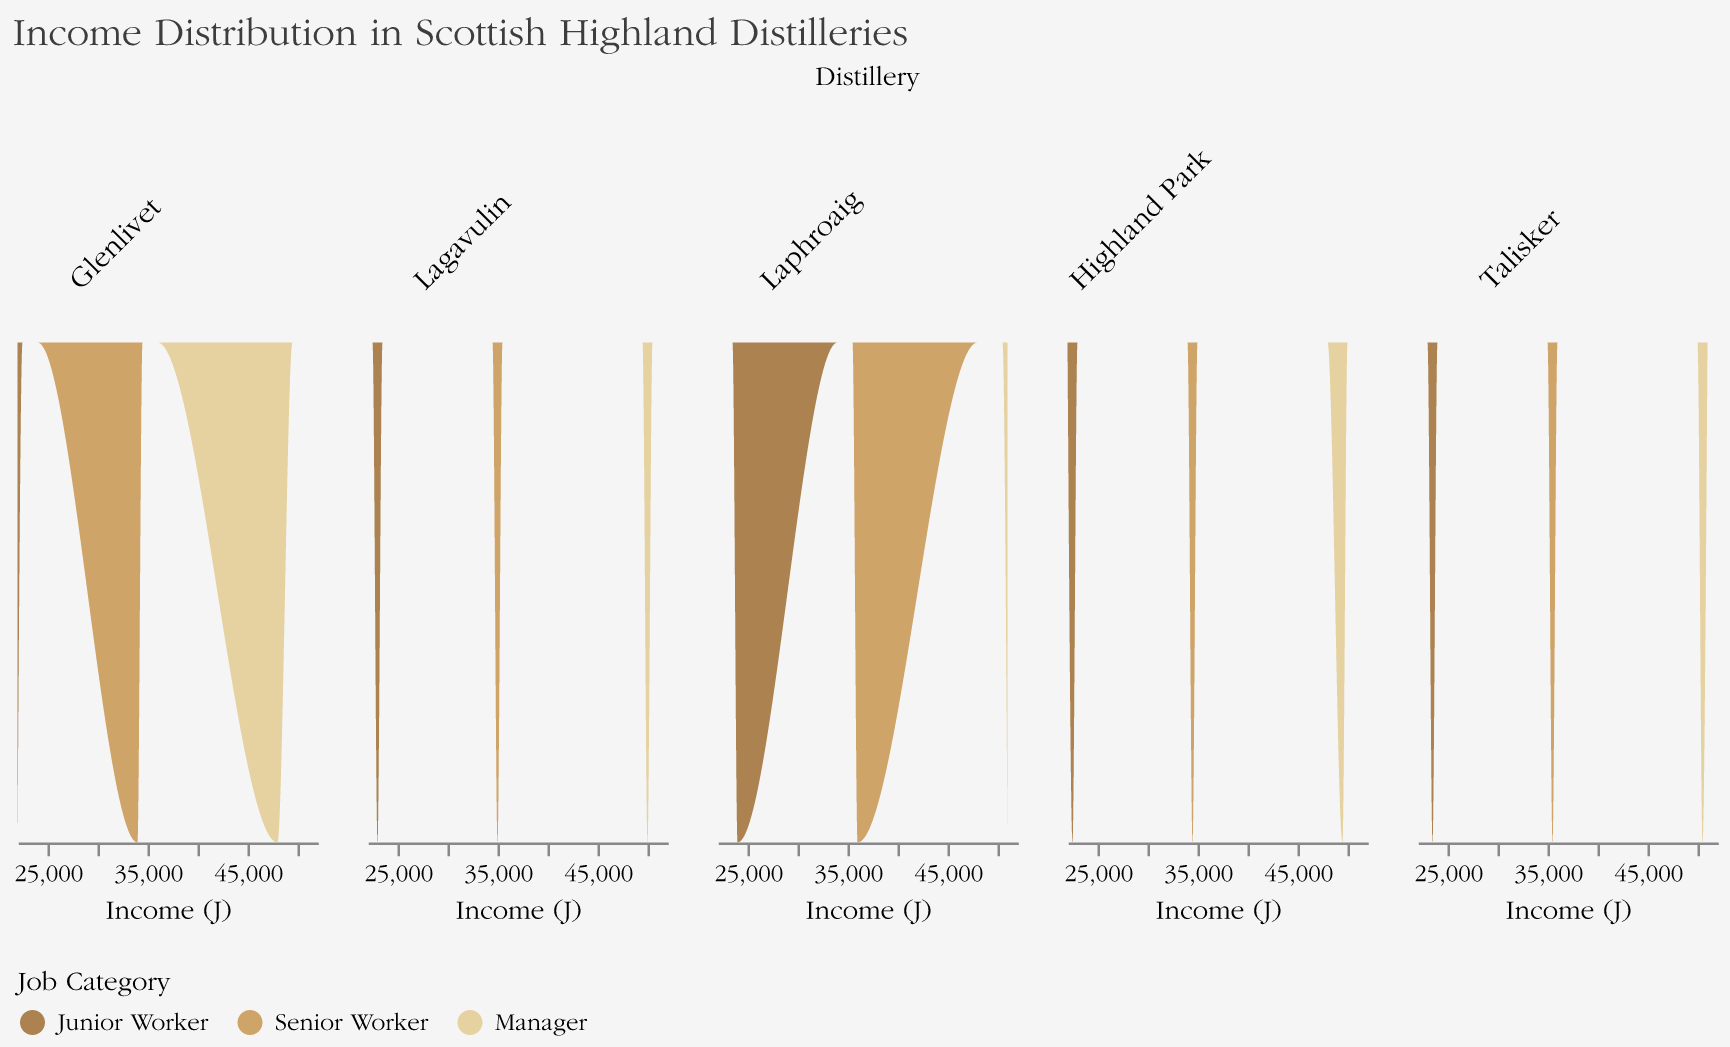What's the title of the plot? The title of the plot is displayed at the top and reads "Income Distribution in Scottish Highland Distilleries".
Answer: Income Distribution in Scottish Highland Distilleries What is the income range covered in the plot? By observing the x-axis labeled "Income (£)", the income range spans from £20,000 to £52,000.
Answer: £20,000 to £52,000 Which job category has the highest income range across all distilleries? Each subplot shows the income distribution for different job categories. Managers have the highest income range in each distillery, generally around £48,000 to £51,000.
Answer: Manager What color represents the "Senior Worker" category? Observing the legend at the bottom, "Senior Worker" is colored in a medium brown shade.
Answer: Medium brown How does the income distribution of "Junior Workers" in Glenlivet compare to "Junior Workers" in Talisker? The income density plots show that Glenlivet Junior Workers typically earn around £22,000, whereas Talisker Junior Workers earn slightly more, around £23,500.
Answer: Talisker Junior Workers earn slightly more Which distillery shows the highest income for managers? Analyzing the subplot for each distillery, Laphroaig shows the highest manager income at £51,000.
Answer: Laphroaig What's the income difference between the highest earning "Senior Worker" and the lowest earning "Manager" across all distilleries? The highest earning "Senior Worker" earns £36,000, whereas the lowest earning "Manager" earns £48,000. The income difference is £48,000 - £36,000.
Answer: £12,000 Which distillery shows the smallest income range within the "Senior Workers" category? To find the smallest income range for "Senior Workers", compare the income ranges in each subplot. Glenlivet shows an income range from £34,000 to £34,000, indicating no variance within this category.
Answer: Glenlivet How does the income distribution of "Managers" in Highland Park differ from those in Lagavulin? Viewing each subplot, "Managers" in Highland Park have an income of £49,500, while those in Lagavulin have an income of £50,000. Lagavulin's managers earn slightly more than Highland Park's.
Answer: Lagavulin's managers earn slightly more 